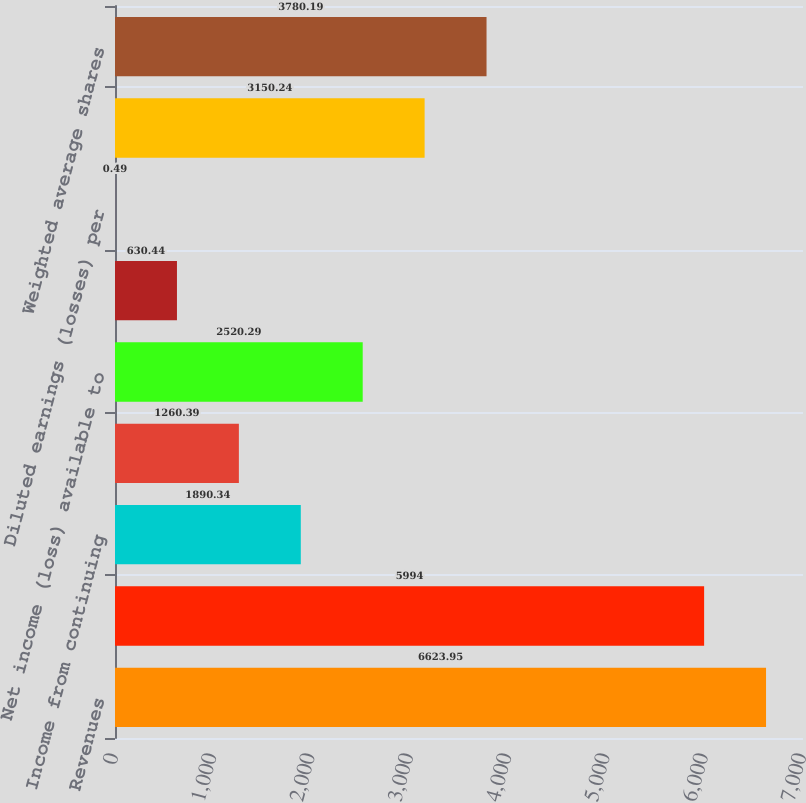<chart> <loc_0><loc_0><loc_500><loc_500><bar_chart><fcel>Revenues<fcel>Benefits losses and expenses<fcel>Income from continuing<fcel>Net income (loss)<fcel>Net income (loss) available to<fcel>Basic earnings (losses) per<fcel>Diluted earnings (losses) per<fcel>Weighted average common shares<fcel>Weighted average shares<nl><fcel>6623.95<fcel>5994<fcel>1890.34<fcel>1260.39<fcel>2520.29<fcel>630.44<fcel>0.49<fcel>3150.24<fcel>3780.19<nl></chart> 